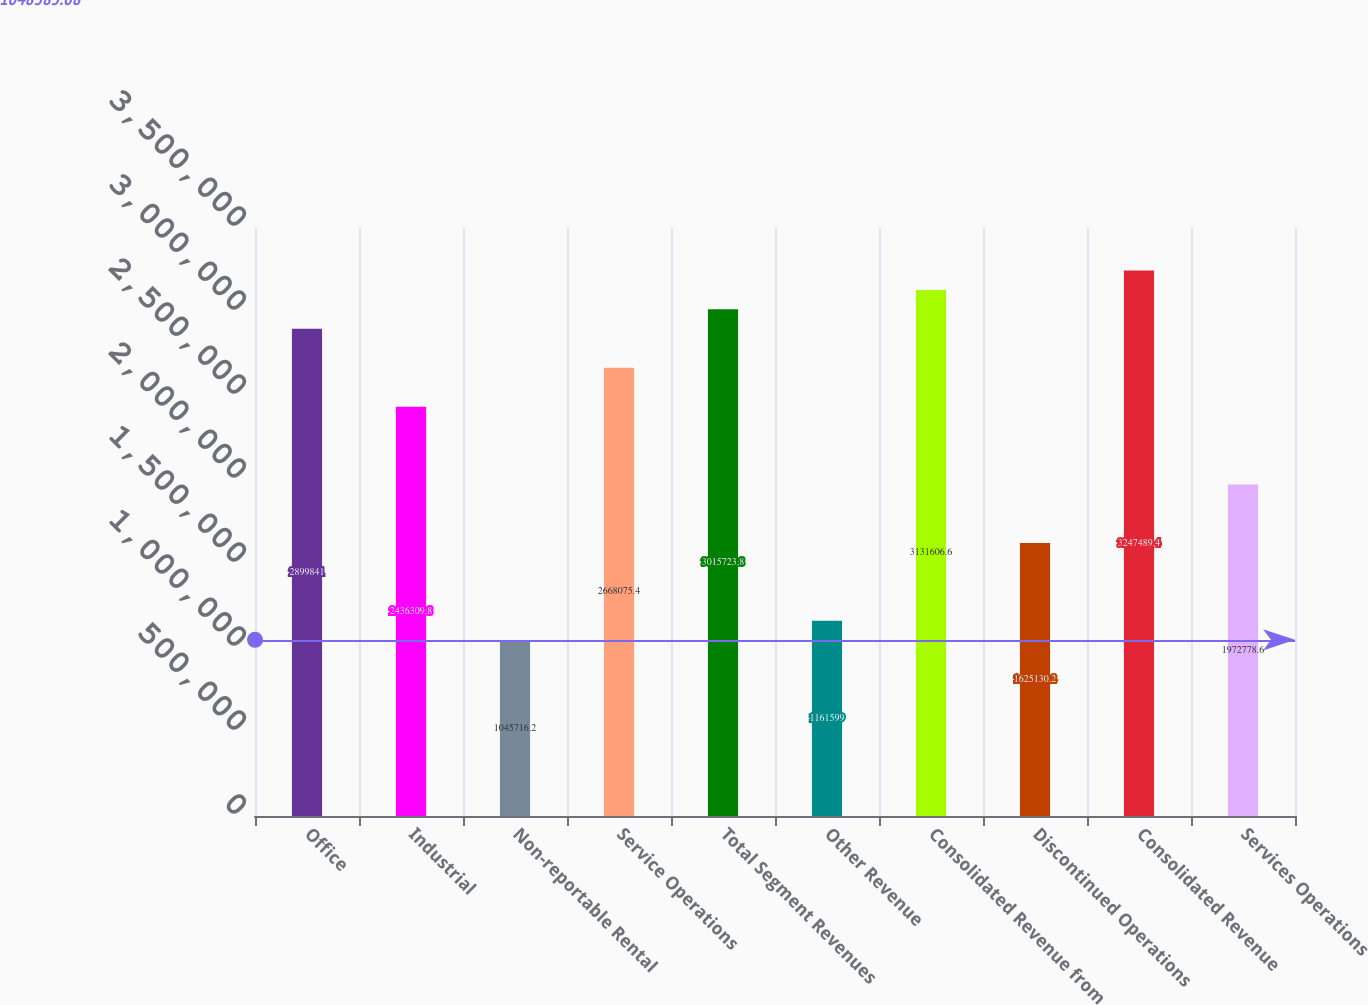Convert chart. <chart><loc_0><loc_0><loc_500><loc_500><bar_chart><fcel>Office<fcel>Industrial<fcel>Non-reportable Rental<fcel>Service Operations<fcel>Total Segment Revenues<fcel>Other Revenue<fcel>Consolidated Revenue from<fcel>Discontinued Operations<fcel>Consolidated Revenue<fcel>Services Operations<nl><fcel>2.89984e+06<fcel>2.43631e+06<fcel>1.04572e+06<fcel>2.66808e+06<fcel>3.01572e+06<fcel>1.1616e+06<fcel>3.13161e+06<fcel>1.62513e+06<fcel>3.24749e+06<fcel>1.97278e+06<nl></chart> 